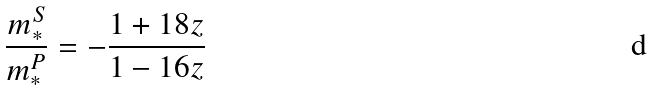<formula> <loc_0><loc_0><loc_500><loc_500>\frac { m _ { * } ^ { S } } { m _ { * } ^ { P } } = - \frac { 1 + 1 8 z } { 1 - 1 6 z }</formula> 